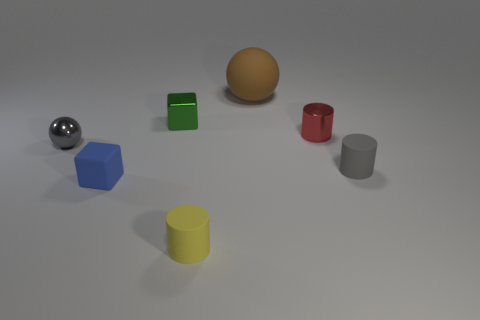Add 3 small green things. How many objects exist? 10 Subtract all cylinders. How many objects are left? 4 Add 3 big green rubber cubes. How many big green rubber cubes exist? 3 Subtract 0 blue spheres. How many objects are left? 7 Subtract all large cylinders. Subtract all small cubes. How many objects are left? 5 Add 4 tiny metallic objects. How many tiny metallic objects are left? 7 